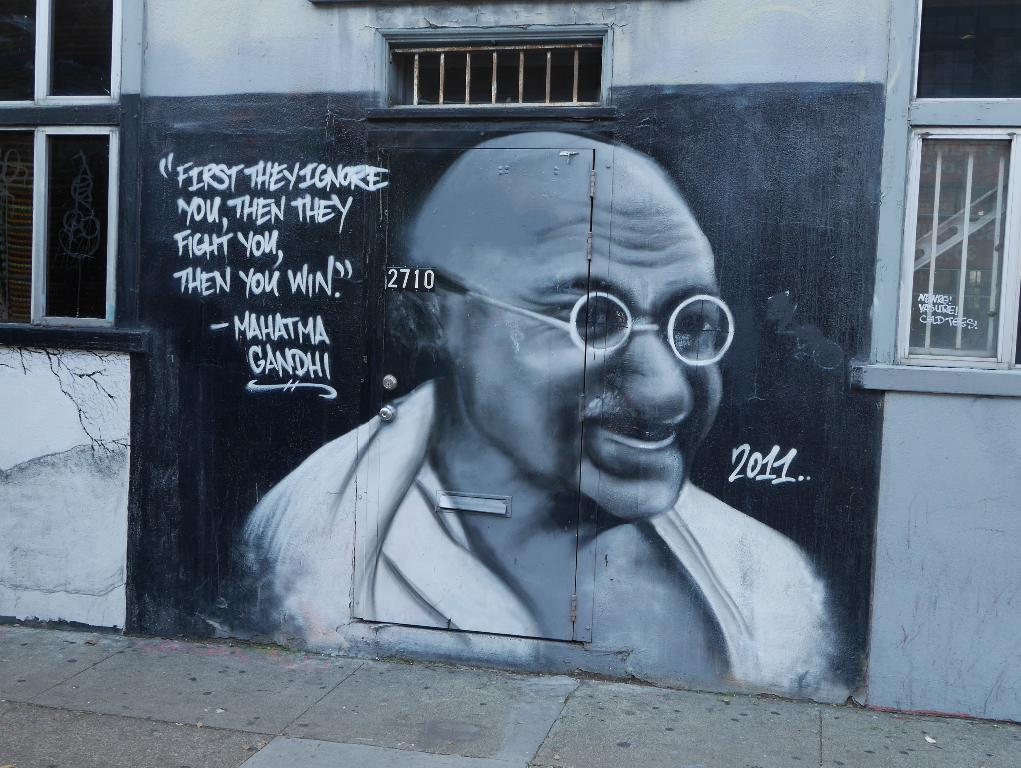What is the main subject of the image on the wall? There is an image of Mahatma Gandhi in the middle of the wall. What can be seen on either side of the image of Mahatma Gandhi? There are windows on either side of the image of Mahatma Gandhi. What type of animals can be seen in the zoo in the image? There is no zoo present in the image; it features an image of Mahatma Gandhi and windows on either side. What is the cast of the movie that is being filmed in the image? There is no movie being filmed in the image; it only contains an image of Mahatma Gandhi and windows. 